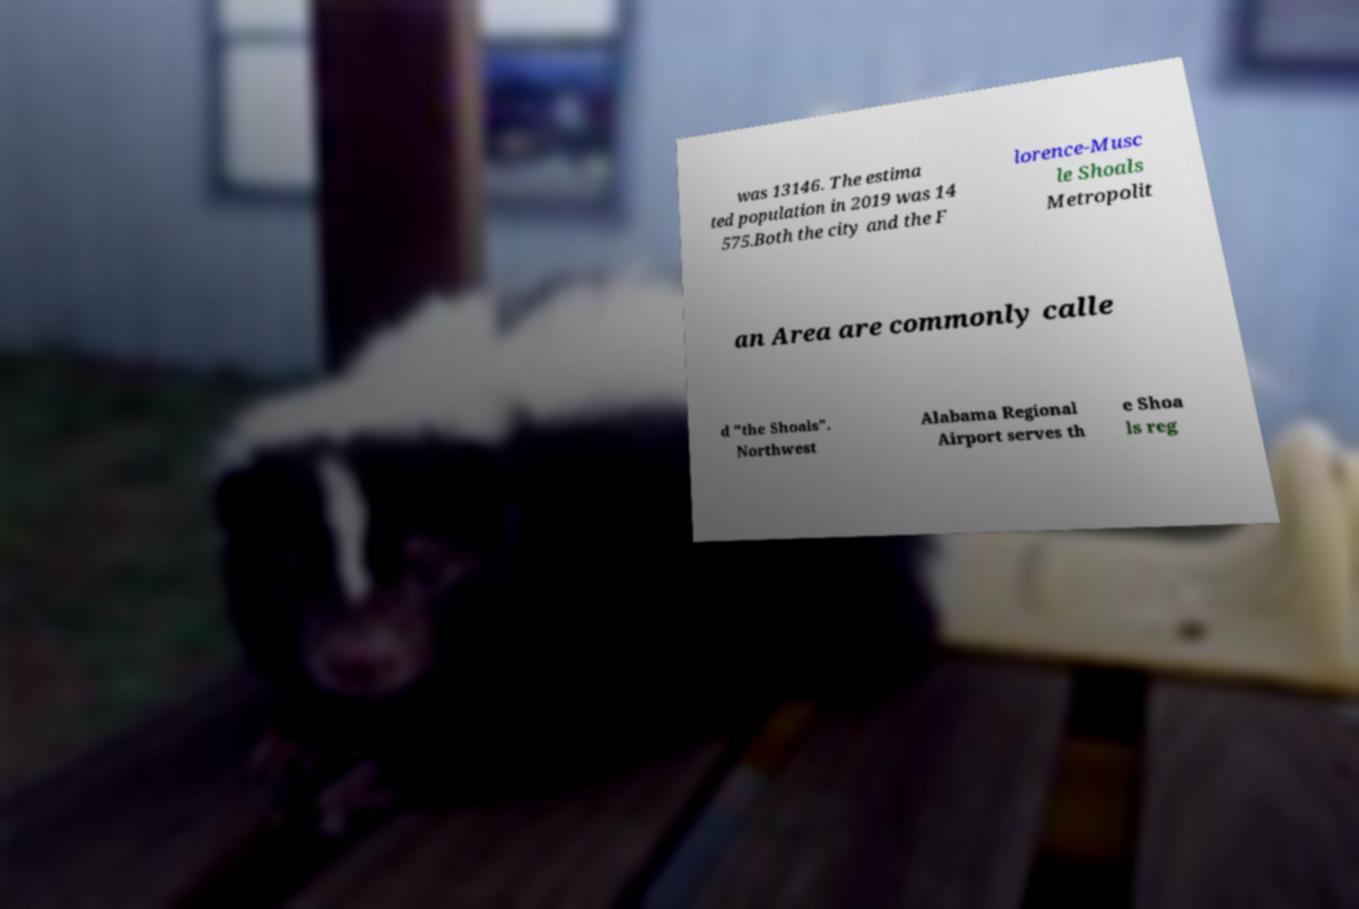Can you read and provide the text displayed in the image?This photo seems to have some interesting text. Can you extract and type it out for me? was 13146. The estima ted population in 2019 was 14 575.Both the city and the F lorence-Musc le Shoals Metropolit an Area are commonly calle d "the Shoals". Northwest Alabama Regional Airport serves th e Shoa ls reg 